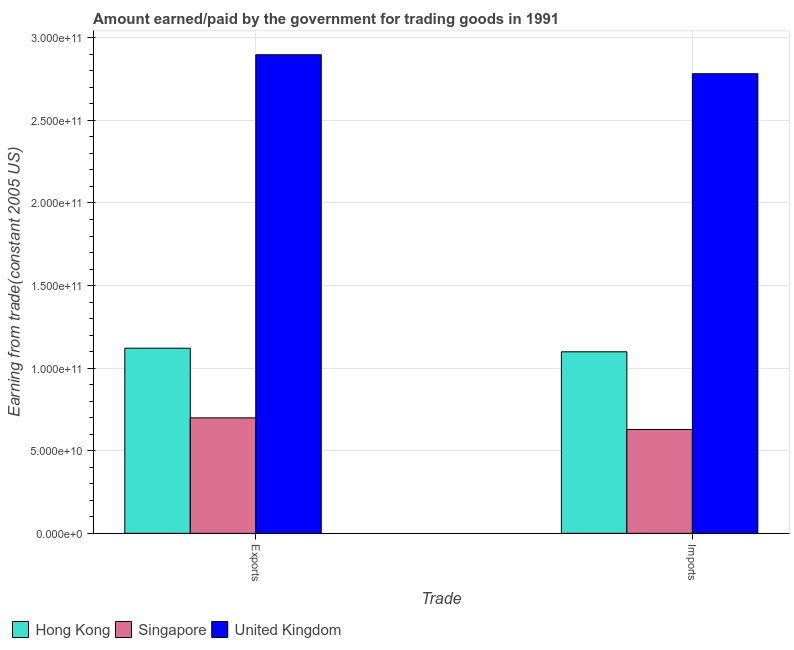How many groups of bars are there?
Your answer should be compact. 2. What is the label of the 1st group of bars from the left?
Your answer should be very brief. Exports. What is the amount paid for imports in Hong Kong?
Your answer should be compact. 1.10e+11. Across all countries, what is the maximum amount paid for imports?
Make the answer very short. 2.78e+11. Across all countries, what is the minimum amount earned from exports?
Keep it short and to the point. 6.99e+1. In which country was the amount earned from exports minimum?
Offer a terse response. Singapore. What is the total amount earned from exports in the graph?
Provide a short and direct response. 4.72e+11. What is the difference between the amount earned from exports in Singapore and that in Hong Kong?
Your answer should be compact. -4.22e+1. What is the difference between the amount paid for imports in United Kingdom and the amount earned from exports in Singapore?
Provide a short and direct response. 2.08e+11. What is the average amount earned from exports per country?
Provide a succinct answer. 1.57e+11. What is the difference between the amount earned from exports and amount paid for imports in Hong Kong?
Give a very brief answer. 2.17e+09. What is the ratio of the amount paid for imports in Singapore to that in Hong Kong?
Make the answer very short. 0.57. Is the amount paid for imports in Hong Kong less than that in United Kingdom?
Your answer should be compact. Yes. What does the 3rd bar from the left in Imports represents?
Your answer should be very brief. United Kingdom. What does the 1st bar from the right in Imports represents?
Your answer should be compact. United Kingdom. What is the difference between two consecutive major ticks on the Y-axis?
Your answer should be very brief. 5.00e+1. Does the graph contain any zero values?
Give a very brief answer. No. Does the graph contain grids?
Your answer should be very brief. Yes. How are the legend labels stacked?
Keep it short and to the point. Horizontal. What is the title of the graph?
Your answer should be compact. Amount earned/paid by the government for trading goods in 1991. What is the label or title of the X-axis?
Ensure brevity in your answer.  Trade. What is the label or title of the Y-axis?
Ensure brevity in your answer.  Earning from trade(constant 2005 US). What is the Earning from trade(constant 2005 US) in Hong Kong in Exports?
Keep it short and to the point. 1.12e+11. What is the Earning from trade(constant 2005 US) of Singapore in Exports?
Offer a terse response. 6.99e+1. What is the Earning from trade(constant 2005 US) of United Kingdom in Exports?
Offer a terse response. 2.90e+11. What is the Earning from trade(constant 2005 US) in Hong Kong in Imports?
Offer a terse response. 1.10e+11. What is the Earning from trade(constant 2005 US) in Singapore in Imports?
Your response must be concise. 6.29e+1. What is the Earning from trade(constant 2005 US) in United Kingdom in Imports?
Give a very brief answer. 2.78e+11. Across all Trade, what is the maximum Earning from trade(constant 2005 US) of Hong Kong?
Your answer should be compact. 1.12e+11. Across all Trade, what is the maximum Earning from trade(constant 2005 US) in Singapore?
Provide a succinct answer. 6.99e+1. Across all Trade, what is the maximum Earning from trade(constant 2005 US) in United Kingdom?
Ensure brevity in your answer.  2.90e+11. Across all Trade, what is the minimum Earning from trade(constant 2005 US) of Hong Kong?
Provide a succinct answer. 1.10e+11. Across all Trade, what is the minimum Earning from trade(constant 2005 US) of Singapore?
Your answer should be compact. 6.29e+1. Across all Trade, what is the minimum Earning from trade(constant 2005 US) of United Kingdom?
Provide a succinct answer. 2.78e+11. What is the total Earning from trade(constant 2005 US) of Hong Kong in the graph?
Ensure brevity in your answer.  2.22e+11. What is the total Earning from trade(constant 2005 US) in Singapore in the graph?
Your answer should be compact. 1.33e+11. What is the total Earning from trade(constant 2005 US) in United Kingdom in the graph?
Make the answer very short. 5.68e+11. What is the difference between the Earning from trade(constant 2005 US) of Hong Kong in Exports and that in Imports?
Make the answer very short. 2.17e+09. What is the difference between the Earning from trade(constant 2005 US) in Singapore in Exports and that in Imports?
Give a very brief answer. 7.04e+09. What is the difference between the Earning from trade(constant 2005 US) of United Kingdom in Exports and that in Imports?
Keep it short and to the point. 1.15e+1. What is the difference between the Earning from trade(constant 2005 US) of Hong Kong in Exports and the Earning from trade(constant 2005 US) of Singapore in Imports?
Provide a short and direct response. 4.92e+1. What is the difference between the Earning from trade(constant 2005 US) in Hong Kong in Exports and the Earning from trade(constant 2005 US) in United Kingdom in Imports?
Provide a short and direct response. -1.66e+11. What is the difference between the Earning from trade(constant 2005 US) in Singapore in Exports and the Earning from trade(constant 2005 US) in United Kingdom in Imports?
Your answer should be compact. -2.08e+11. What is the average Earning from trade(constant 2005 US) in Hong Kong per Trade?
Provide a short and direct response. 1.11e+11. What is the average Earning from trade(constant 2005 US) of Singapore per Trade?
Give a very brief answer. 6.64e+1. What is the average Earning from trade(constant 2005 US) of United Kingdom per Trade?
Your answer should be compact. 2.84e+11. What is the difference between the Earning from trade(constant 2005 US) of Hong Kong and Earning from trade(constant 2005 US) of Singapore in Exports?
Your response must be concise. 4.22e+1. What is the difference between the Earning from trade(constant 2005 US) in Hong Kong and Earning from trade(constant 2005 US) in United Kingdom in Exports?
Offer a terse response. -1.78e+11. What is the difference between the Earning from trade(constant 2005 US) of Singapore and Earning from trade(constant 2005 US) of United Kingdom in Exports?
Give a very brief answer. -2.20e+11. What is the difference between the Earning from trade(constant 2005 US) in Hong Kong and Earning from trade(constant 2005 US) in Singapore in Imports?
Your answer should be compact. 4.70e+1. What is the difference between the Earning from trade(constant 2005 US) of Hong Kong and Earning from trade(constant 2005 US) of United Kingdom in Imports?
Keep it short and to the point. -1.68e+11. What is the difference between the Earning from trade(constant 2005 US) in Singapore and Earning from trade(constant 2005 US) in United Kingdom in Imports?
Keep it short and to the point. -2.15e+11. What is the ratio of the Earning from trade(constant 2005 US) of Hong Kong in Exports to that in Imports?
Make the answer very short. 1.02. What is the ratio of the Earning from trade(constant 2005 US) in Singapore in Exports to that in Imports?
Your answer should be compact. 1.11. What is the ratio of the Earning from trade(constant 2005 US) in United Kingdom in Exports to that in Imports?
Give a very brief answer. 1.04. What is the difference between the highest and the second highest Earning from trade(constant 2005 US) in Hong Kong?
Provide a succinct answer. 2.17e+09. What is the difference between the highest and the second highest Earning from trade(constant 2005 US) of Singapore?
Your answer should be very brief. 7.04e+09. What is the difference between the highest and the second highest Earning from trade(constant 2005 US) of United Kingdom?
Give a very brief answer. 1.15e+1. What is the difference between the highest and the lowest Earning from trade(constant 2005 US) in Hong Kong?
Your answer should be compact. 2.17e+09. What is the difference between the highest and the lowest Earning from trade(constant 2005 US) in Singapore?
Give a very brief answer. 7.04e+09. What is the difference between the highest and the lowest Earning from trade(constant 2005 US) in United Kingdom?
Your answer should be very brief. 1.15e+1. 